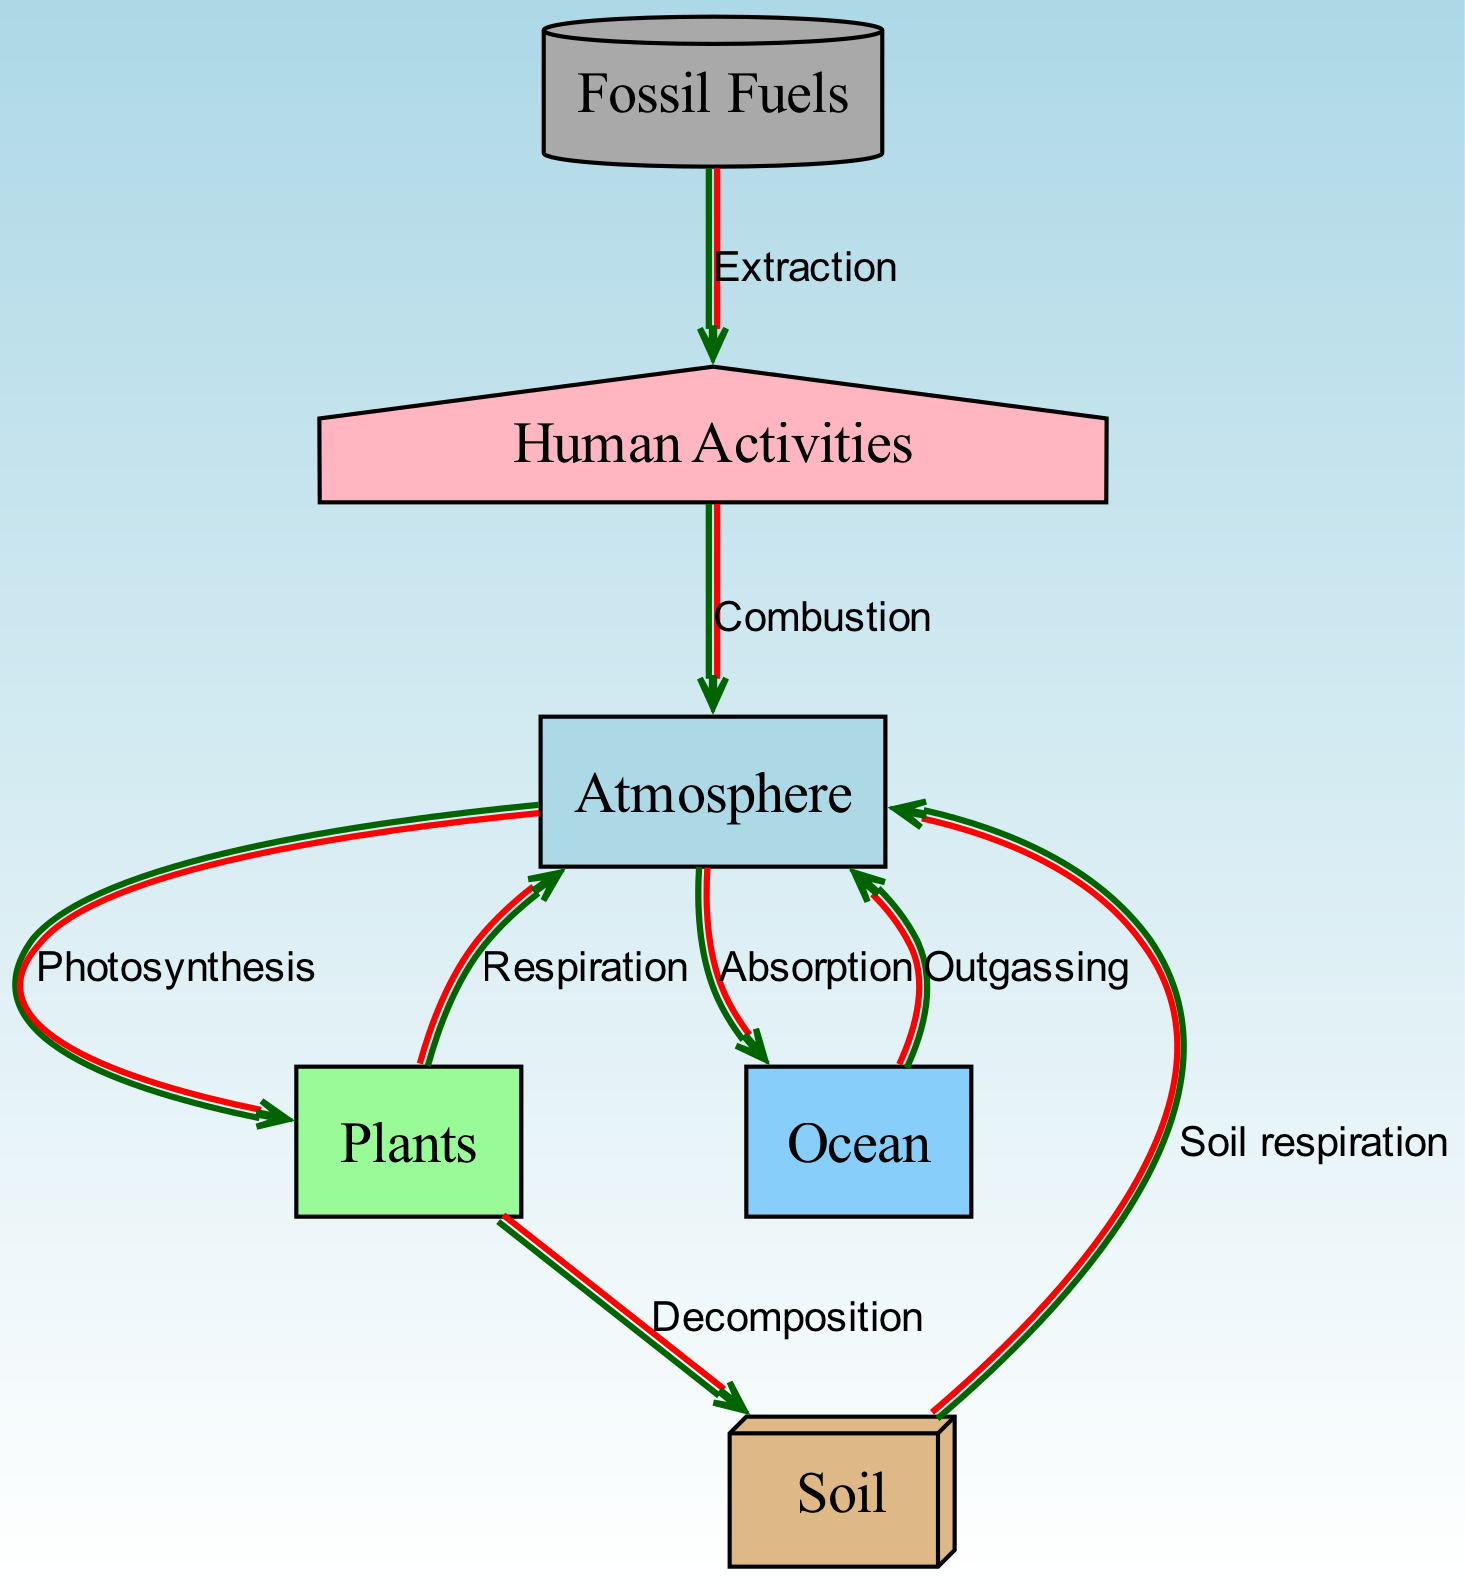What are the nodes in the carbon cycle? The nodes in the diagram represent different components of the carbon cycle, which include atmosphere, plants, soil, ocean, fossil fuels, and human activities.
Answer: atmosphere, plants, soil, ocean, fossil fuels, human activities How many edges are there in this diagram? An edge represents the flow of carbon between two nodes. Upon counting the edges connecting the nodes, it can be determined that there are eight edges in total.
Answer: 8 What process flows from plants to the atmosphere? From the diagram, the edge connecting 'plants' to 'atmosphere' is labeled 'Respiration', indicating that carbon is released back into the atmosphere through this process.
Answer: Respiration Which node receives carbon from human activities? The edge leading from 'human activities' to 'atmosphere' shows that carbon is released into the atmosphere from human activities through the process labeled 'Combustion'.
Answer: atmosphere What is the relationship between the ocean and the atmosphere? There are two distinct edges between the 'ocean' and 'atmosphere': one labeled 'Absorption' (from atmosphere to ocean) and another labeled 'Outgassing' (from ocean to atmosphere), indicating that carbon is exchanged in both directions between these two components.
Answer: Absorption, Outgassing What happens to carbon when plants die? The edge labeled 'Decomposition' indicates that when plants die, carbon is transferred from plants to the soil, where it is broken down.
Answer: Decomposition Which process facilitates the flow of carbon from the atmosphere to the ocean? The flow from 'atmosphere' to 'ocean' is identified in the diagram as 'Absorption', which describes the process where the ocean absorbs carbon dioxide from the atmosphere.
Answer: Absorption Which node is associated with fossil fuels? The edge labeled 'Extraction' connects 'fossil fuels' to 'human activities', showing that fossil fuels are extracted for use in various human activities, linking them directly to this component.
Answer: human activities 